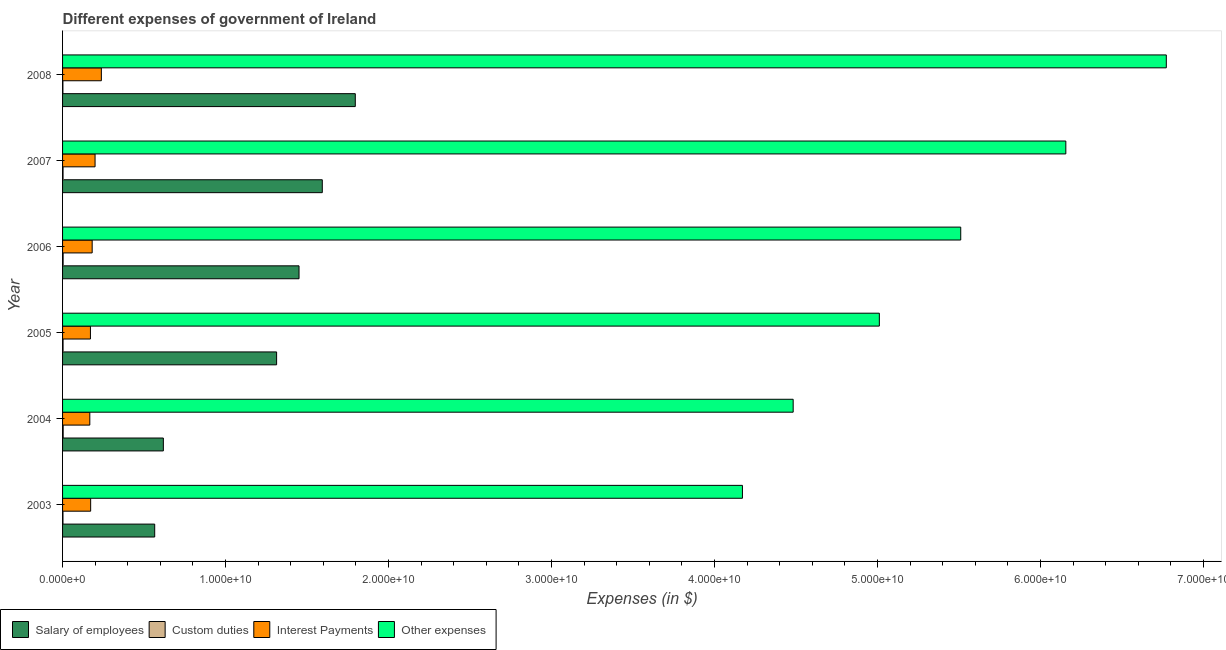How many groups of bars are there?
Your response must be concise. 6. How many bars are there on the 2nd tick from the top?
Offer a very short reply. 4. How many bars are there on the 4th tick from the bottom?
Offer a terse response. 4. What is the amount spent on custom duties in 2005?
Your answer should be compact. 3.06e+07. Across all years, what is the maximum amount spent on custom duties?
Your answer should be very brief. 3.67e+07. Across all years, what is the minimum amount spent on interest payments?
Make the answer very short. 1.67e+09. What is the total amount spent on other expenses in the graph?
Your answer should be very brief. 3.21e+11. What is the difference between the amount spent on interest payments in 2007 and that in 2008?
Provide a succinct answer. -3.86e+08. What is the difference between the amount spent on interest payments in 2003 and the amount spent on custom duties in 2006?
Offer a terse response. 1.69e+09. What is the average amount spent on other expenses per year?
Make the answer very short. 5.35e+1. In the year 2003, what is the difference between the amount spent on other expenses and amount spent on interest payments?
Your answer should be compact. 4.00e+1. What is the ratio of the amount spent on salary of employees in 2005 to that in 2006?
Make the answer very short. 0.91. What is the difference between the highest and the second highest amount spent on salary of employees?
Give a very brief answer. 2.02e+09. What is the difference between the highest and the lowest amount spent on interest payments?
Offer a terse response. 7.08e+08. In how many years, is the amount spent on custom duties greater than the average amount spent on custom duties taken over all years?
Offer a terse response. 4. What does the 1st bar from the top in 2004 represents?
Offer a terse response. Other expenses. What does the 3rd bar from the bottom in 2008 represents?
Your answer should be compact. Interest Payments. Are all the bars in the graph horizontal?
Offer a terse response. Yes. What is the difference between two consecutive major ticks on the X-axis?
Offer a very short reply. 1.00e+1. Does the graph contain grids?
Your answer should be compact. No. Where does the legend appear in the graph?
Your answer should be compact. Bottom left. What is the title of the graph?
Make the answer very short. Different expenses of government of Ireland. What is the label or title of the X-axis?
Your answer should be compact. Expenses (in $). What is the Expenses (in $) of Salary of employees in 2003?
Offer a terse response. 5.65e+09. What is the Expenses (in $) in Custom duties in 2003?
Provide a short and direct response. 2.45e+07. What is the Expenses (in $) of Interest Payments in 2003?
Offer a very short reply. 1.72e+09. What is the Expenses (in $) of Other expenses in 2003?
Offer a terse response. 4.17e+1. What is the Expenses (in $) in Salary of employees in 2004?
Keep it short and to the point. 6.18e+09. What is the Expenses (in $) in Custom duties in 2004?
Offer a terse response. 3.67e+07. What is the Expenses (in $) in Interest Payments in 2004?
Ensure brevity in your answer.  1.67e+09. What is the Expenses (in $) of Other expenses in 2004?
Your answer should be very brief. 4.48e+1. What is the Expenses (in $) of Salary of employees in 2005?
Provide a short and direct response. 1.31e+1. What is the Expenses (in $) of Custom duties in 2005?
Offer a very short reply. 3.06e+07. What is the Expenses (in $) in Interest Payments in 2005?
Make the answer very short. 1.71e+09. What is the Expenses (in $) of Other expenses in 2005?
Make the answer very short. 5.01e+1. What is the Expenses (in $) in Salary of employees in 2006?
Provide a succinct answer. 1.45e+1. What is the Expenses (in $) of Custom duties in 2006?
Offer a terse response. 3.44e+07. What is the Expenses (in $) of Interest Payments in 2006?
Offer a terse response. 1.82e+09. What is the Expenses (in $) of Other expenses in 2006?
Keep it short and to the point. 5.51e+1. What is the Expenses (in $) in Salary of employees in 2007?
Your response must be concise. 1.59e+1. What is the Expenses (in $) of Custom duties in 2007?
Offer a very short reply. 2.95e+07. What is the Expenses (in $) of Interest Payments in 2007?
Keep it short and to the point. 1.99e+09. What is the Expenses (in $) in Other expenses in 2007?
Your answer should be very brief. 6.16e+1. What is the Expenses (in $) of Salary of employees in 2008?
Your answer should be very brief. 1.80e+1. What is the Expenses (in $) of Custom duties in 2008?
Make the answer very short. 2.06e+07. What is the Expenses (in $) in Interest Payments in 2008?
Provide a succinct answer. 2.38e+09. What is the Expenses (in $) in Other expenses in 2008?
Your answer should be compact. 6.77e+1. Across all years, what is the maximum Expenses (in $) in Salary of employees?
Provide a short and direct response. 1.80e+1. Across all years, what is the maximum Expenses (in $) in Custom duties?
Make the answer very short. 3.67e+07. Across all years, what is the maximum Expenses (in $) in Interest Payments?
Provide a succinct answer. 2.38e+09. Across all years, what is the maximum Expenses (in $) in Other expenses?
Give a very brief answer. 6.77e+1. Across all years, what is the minimum Expenses (in $) in Salary of employees?
Your response must be concise. 5.65e+09. Across all years, what is the minimum Expenses (in $) in Custom duties?
Your answer should be very brief. 2.06e+07. Across all years, what is the minimum Expenses (in $) of Interest Payments?
Your answer should be compact. 1.67e+09. Across all years, what is the minimum Expenses (in $) of Other expenses?
Ensure brevity in your answer.  4.17e+1. What is the total Expenses (in $) of Salary of employees in the graph?
Your answer should be compact. 7.34e+1. What is the total Expenses (in $) in Custom duties in the graph?
Offer a very short reply. 1.76e+08. What is the total Expenses (in $) of Interest Payments in the graph?
Give a very brief answer. 1.13e+1. What is the total Expenses (in $) of Other expenses in the graph?
Provide a succinct answer. 3.21e+11. What is the difference between the Expenses (in $) of Salary of employees in 2003 and that in 2004?
Offer a terse response. -5.31e+08. What is the difference between the Expenses (in $) in Custom duties in 2003 and that in 2004?
Give a very brief answer. -1.22e+07. What is the difference between the Expenses (in $) in Interest Payments in 2003 and that in 2004?
Provide a short and direct response. 5.13e+07. What is the difference between the Expenses (in $) of Other expenses in 2003 and that in 2004?
Your response must be concise. -3.11e+09. What is the difference between the Expenses (in $) in Salary of employees in 2003 and that in 2005?
Offer a terse response. -7.48e+09. What is the difference between the Expenses (in $) of Custom duties in 2003 and that in 2005?
Provide a succinct answer. -6.12e+06. What is the difference between the Expenses (in $) in Interest Payments in 2003 and that in 2005?
Give a very brief answer. 1.34e+07. What is the difference between the Expenses (in $) of Other expenses in 2003 and that in 2005?
Make the answer very short. -8.40e+09. What is the difference between the Expenses (in $) in Salary of employees in 2003 and that in 2006?
Your answer should be compact. -8.85e+09. What is the difference between the Expenses (in $) in Custom duties in 2003 and that in 2006?
Your answer should be compact. -9.89e+06. What is the difference between the Expenses (in $) of Interest Payments in 2003 and that in 2006?
Make the answer very short. -9.33e+07. What is the difference between the Expenses (in $) in Other expenses in 2003 and that in 2006?
Provide a succinct answer. -1.34e+1. What is the difference between the Expenses (in $) in Salary of employees in 2003 and that in 2007?
Provide a short and direct response. -1.03e+1. What is the difference between the Expenses (in $) of Custom duties in 2003 and that in 2007?
Keep it short and to the point. -5.03e+06. What is the difference between the Expenses (in $) of Interest Payments in 2003 and that in 2007?
Keep it short and to the point. -2.71e+08. What is the difference between the Expenses (in $) of Other expenses in 2003 and that in 2007?
Provide a short and direct response. -1.98e+1. What is the difference between the Expenses (in $) in Salary of employees in 2003 and that in 2008?
Offer a very short reply. -1.23e+1. What is the difference between the Expenses (in $) of Custom duties in 2003 and that in 2008?
Your response must be concise. 3.87e+06. What is the difference between the Expenses (in $) in Interest Payments in 2003 and that in 2008?
Your answer should be compact. -6.56e+08. What is the difference between the Expenses (in $) in Other expenses in 2003 and that in 2008?
Offer a terse response. -2.60e+1. What is the difference between the Expenses (in $) in Salary of employees in 2004 and that in 2005?
Offer a terse response. -6.95e+09. What is the difference between the Expenses (in $) in Custom duties in 2004 and that in 2005?
Offer a very short reply. 6.12e+06. What is the difference between the Expenses (in $) of Interest Payments in 2004 and that in 2005?
Offer a terse response. -3.79e+07. What is the difference between the Expenses (in $) in Other expenses in 2004 and that in 2005?
Give a very brief answer. -5.29e+09. What is the difference between the Expenses (in $) in Salary of employees in 2004 and that in 2006?
Ensure brevity in your answer.  -8.32e+09. What is the difference between the Expenses (in $) of Custom duties in 2004 and that in 2006?
Offer a terse response. 2.35e+06. What is the difference between the Expenses (in $) in Interest Payments in 2004 and that in 2006?
Keep it short and to the point. -1.45e+08. What is the difference between the Expenses (in $) in Other expenses in 2004 and that in 2006?
Your response must be concise. -1.03e+1. What is the difference between the Expenses (in $) of Salary of employees in 2004 and that in 2007?
Your response must be concise. -9.75e+09. What is the difference between the Expenses (in $) in Custom duties in 2004 and that in 2007?
Give a very brief answer. 7.21e+06. What is the difference between the Expenses (in $) in Interest Payments in 2004 and that in 2007?
Provide a succinct answer. -3.22e+08. What is the difference between the Expenses (in $) in Other expenses in 2004 and that in 2007?
Make the answer very short. -1.67e+1. What is the difference between the Expenses (in $) of Salary of employees in 2004 and that in 2008?
Your answer should be compact. -1.18e+1. What is the difference between the Expenses (in $) in Custom duties in 2004 and that in 2008?
Your answer should be compact. 1.61e+07. What is the difference between the Expenses (in $) of Interest Payments in 2004 and that in 2008?
Offer a terse response. -7.08e+08. What is the difference between the Expenses (in $) of Other expenses in 2004 and that in 2008?
Ensure brevity in your answer.  -2.29e+1. What is the difference between the Expenses (in $) in Salary of employees in 2005 and that in 2006?
Offer a very short reply. -1.38e+09. What is the difference between the Expenses (in $) in Custom duties in 2005 and that in 2006?
Your response must be concise. -3.77e+06. What is the difference between the Expenses (in $) of Interest Payments in 2005 and that in 2006?
Your answer should be compact. -1.07e+08. What is the difference between the Expenses (in $) of Other expenses in 2005 and that in 2006?
Offer a very short reply. -4.99e+09. What is the difference between the Expenses (in $) in Salary of employees in 2005 and that in 2007?
Give a very brief answer. -2.80e+09. What is the difference between the Expenses (in $) in Custom duties in 2005 and that in 2007?
Offer a very short reply. 1.09e+06. What is the difference between the Expenses (in $) of Interest Payments in 2005 and that in 2007?
Make the answer very short. -2.84e+08. What is the difference between the Expenses (in $) of Other expenses in 2005 and that in 2007?
Provide a succinct answer. -1.14e+1. What is the difference between the Expenses (in $) of Salary of employees in 2005 and that in 2008?
Your answer should be very brief. -4.83e+09. What is the difference between the Expenses (in $) of Custom duties in 2005 and that in 2008?
Provide a short and direct response. 9.99e+06. What is the difference between the Expenses (in $) of Interest Payments in 2005 and that in 2008?
Make the answer very short. -6.70e+08. What is the difference between the Expenses (in $) in Other expenses in 2005 and that in 2008?
Make the answer very short. -1.76e+1. What is the difference between the Expenses (in $) in Salary of employees in 2006 and that in 2007?
Provide a succinct answer. -1.43e+09. What is the difference between the Expenses (in $) of Custom duties in 2006 and that in 2007?
Give a very brief answer. 4.86e+06. What is the difference between the Expenses (in $) in Interest Payments in 2006 and that in 2007?
Provide a succinct answer. -1.77e+08. What is the difference between the Expenses (in $) in Other expenses in 2006 and that in 2007?
Offer a terse response. -6.45e+09. What is the difference between the Expenses (in $) in Salary of employees in 2006 and that in 2008?
Provide a succinct answer. -3.45e+09. What is the difference between the Expenses (in $) in Custom duties in 2006 and that in 2008?
Give a very brief answer. 1.38e+07. What is the difference between the Expenses (in $) of Interest Payments in 2006 and that in 2008?
Your response must be concise. -5.63e+08. What is the difference between the Expenses (in $) of Other expenses in 2006 and that in 2008?
Offer a very short reply. -1.26e+1. What is the difference between the Expenses (in $) of Salary of employees in 2007 and that in 2008?
Ensure brevity in your answer.  -2.02e+09. What is the difference between the Expenses (in $) in Custom duties in 2007 and that in 2008?
Ensure brevity in your answer.  8.90e+06. What is the difference between the Expenses (in $) in Interest Payments in 2007 and that in 2008?
Offer a very short reply. -3.86e+08. What is the difference between the Expenses (in $) of Other expenses in 2007 and that in 2008?
Give a very brief answer. -6.16e+09. What is the difference between the Expenses (in $) of Salary of employees in 2003 and the Expenses (in $) of Custom duties in 2004?
Ensure brevity in your answer.  5.62e+09. What is the difference between the Expenses (in $) of Salary of employees in 2003 and the Expenses (in $) of Interest Payments in 2004?
Your answer should be very brief. 3.98e+09. What is the difference between the Expenses (in $) of Salary of employees in 2003 and the Expenses (in $) of Other expenses in 2004?
Your answer should be very brief. -3.92e+1. What is the difference between the Expenses (in $) in Custom duties in 2003 and the Expenses (in $) in Interest Payments in 2004?
Your answer should be compact. -1.65e+09. What is the difference between the Expenses (in $) in Custom duties in 2003 and the Expenses (in $) in Other expenses in 2004?
Offer a very short reply. -4.48e+1. What is the difference between the Expenses (in $) in Interest Payments in 2003 and the Expenses (in $) in Other expenses in 2004?
Offer a terse response. -4.31e+1. What is the difference between the Expenses (in $) of Salary of employees in 2003 and the Expenses (in $) of Custom duties in 2005?
Offer a terse response. 5.62e+09. What is the difference between the Expenses (in $) of Salary of employees in 2003 and the Expenses (in $) of Interest Payments in 2005?
Give a very brief answer. 3.94e+09. What is the difference between the Expenses (in $) of Salary of employees in 2003 and the Expenses (in $) of Other expenses in 2005?
Your answer should be compact. -4.45e+1. What is the difference between the Expenses (in $) in Custom duties in 2003 and the Expenses (in $) in Interest Payments in 2005?
Provide a succinct answer. -1.69e+09. What is the difference between the Expenses (in $) of Custom duties in 2003 and the Expenses (in $) of Other expenses in 2005?
Offer a terse response. -5.01e+1. What is the difference between the Expenses (in $) of Interest Payments in 2003 and the Expenses (in $) of Other expenses in 2005?
Ensure brevity in your answer.  -4.84e+1. What is the difference between the Expenses (in $) of Salary of employees in 2003 and the Expenses (in $) of Custom duties in 2006?
Your answer should be compact. 5.62e+09. What is the difference between the Expenses (in $) of Salary of employees in 2003 and the Expenses (in $) of Interest Payments in 2006?
Provide a short and direct response. 3.84e+09. What is the difference between the Expenses (in $) in Salary of employees in 2003 and the Expenses (in $) in Other expenses in 2006?
Your answer should be very brief. -4.95e+1. What is the difference between the Expenses (in $) of Custom duties in 2003 and the Expenses (in $) of Interest Payments in 2006?
Ensure brevity in your answer.  -1.79e+09. What is the difference between the Expenses (in $) of Custom duties in 2003 and the Expenses (in $) of Other expenses in 2006?
Offer a terse response. -5.51e+1. What is the difference between the Expenses (in $) of Interest Payments in 2003 and the Expenses (in $) of Other expenses in 2006?
Your answer should be compact. -5.34e+1. What is the difference between the Expenses (in $) in Salary of employees in 2003 and the Expenses (in $) in Custom duties in 2007?
Offer a terse response. 5.62e+09. What is the difference between the Expenses (in $) in Salary of employees in 2003 and the Expenses (in $) in Interest Payments in 2007?
Offer a terse response. 3.66e+09. What is the difference between the Expenses (in $) in Salary of employees in 2003 and the Expenses (in $) in Other expenses in 2007?
Offer a very short reply. -5.59e+1. What is the difference between the Expenses (in $) in Custom duties in 2003 and the Expenses (in $) in Interest Payments in 2007?
Your answer should be very brief. -1.97e+09. What is the difference between the Expenses (in $) in Custom duties in 2003 and the Expenses (in $) in Other expenses in 2007?
Provide a short and direct response. -6.15e+1. What is the difference between the Expenses (in $) in Interest Payments in 2003 and the Expenses (in $) in Other expenses in 2007?
Provide a succinct answer. -5.98e+1. What is the difference between the Expenses (in $) of Salary of employees in 2003 and the Expenses (in $) of Custom duties in 2008?
Provide a succinct answer. 5.63e+09. What is the difference between the Expenses (in $) in Salary of employees in 2003 and the Expenses (in $) in Interest Payments in 2008?
Make the answer very short. 3.27e+09. What is the difference between the Expenses (in $) in Salary of employees in 2003 and the Expenses (in $) in Other expenses in 2008?
Provide a succinct answer. -6.21e+1. What is the difference between the Expenses (in $) in Custom duties in 2003 and the Expenses (in $) in Interest Payments in 2008?
Your answer should be very brief. -2.36e+09. What is the difference between the Expenses (in $) of Custom duties in 2003 and the Expenses (in $) of Other expenses in 2008?
Give a very brief answer. -6.77e+1. What is the difference between the Expenses (in $) of Interest Payments in 2003 and the Expenses (in $) of Other expenses in 2008?
Provide a succinct answer. -6.60e+1. What is the difference between the Expenses (in $) in Salary of employees in 2004 and the Expenses (in $) in Custom duties in 2005?
Provide a short and direct response. 6.15e+09. What is the difference between the Expenses (in $) of Salary of employees in 2004 and the Expenses (in $) of Interest Payments in 2005?
Provide a succinct answer. 4.47e+09. What is the difference between the Expenses (in $) of Salary of employees in 2004 and the Expenses (in $) of Other expenses in 2005?
Provide a succinct answer. -4.39e+1. What is the difference between the Expenses (in $) of Custom duties in 2004 and the Expenses (in $) of Interest Payments in 2005?
Your response must be concise. -1.67e+09. What is the difference between the Expenses (in $) of Custom duties in 2004 and the Expenses (in $) of Other expenses in 2005?
Provide a succinct answer. -5.01e+1. What is the difference between the Expenses (in $) in Interest Payments in 2004 and the Expenses (in $) in Other expenses in 2005?
Give a very brief answer. -4.84e+1. What is the difference between the Expenses (in $) of Salary of employees in 2004 and the Expenses (in $) of Custom duties in 2006?
Your answer should be compact. 6.15e+09. What is the difference between the Expenses (in $) of Salary of employees in 2004 and the Expenses (in $) of Interest Payments in 2006?
Your answer should be compact. 4.37e+09. What is the difference between the Expenses (in $) in Salary of employees in 2004 and the Expenses (in $) in Other expenses in 2006?
Your answer should be compact. -4.89e+1. What is the difference between the Expenses (in $) of Custom duties in 2004 and the Expenses (in $) of Interest Payments in 2006?
Provide a short and direct response. -1.78e+09. What is the difference between the Expenses (in $) of Custom duties in 2004 and the Expenses (in $) of Other expenses in 2006?
Keep it short and to the point. -5.51e+1. What is the difference between the Expenses (in $) in Interest Payments in 2004 and the Expenses (in $) in Other expenses in 2006?
Keep it short and to the point. -5.34e+1. What is the difference between the Expenses (in $) in Salary of employees in 2004 and the Expenses (in $) in Custom duties in 2007?
Give a very brief answer. 6.15e+09. What is the difference between the Expenses (in $) of Salary of employees in 2004 and the Expenses (in $) of Interest Payments in 2007?
Offer a very short reply. 4.19e+09. What is the difference between the Expenses (in $) of Salary of employees in 2004 and the Expenses (in $) of Other expenses in 2007?
Offer a very short reply. -5.54e+1. What is the difference between the Expenses (in $) in Custom duties in 2004 and the Expenses (in $) in Interest Payments in 2007?
Your answer should be very brief. -1.96e+09. What is the difference between the Expenses (in $) of Custom duties in 2004 and the Expenses (in $) of Other expenses in 2007?
Your answer should be very brief. -6.15e+1. What is the difference between the Expenses (in $) of Interest Payments in 2004 and the Expenses (in $) of Other expenses in 2007?
Offer a terse response. -5.99e+1. What is the difference between the Expenses (in $) in Salary of employees in 2004 and the Expenses (in $) in Custom duties in 2008?
Give a very brief answer. 6.16e+09. What is the difference between the Expenses (in $) of Salary of employees in 2004 and the Expenses (in $) of Interest Payments in 2008?
Make the answer very short. 3.80e+09. What is the difference between the Expenses (in $) of Salary of employees in 2004 and the Expenses (in $) of Other expenses in 2008?
Your response must be concise. -6.15e+1. What is the difference between the Expenses (in $) of Custom duties in 2004 and the Expenses (in $) of Interest Payments in 2008?
Your answer should be very brief. -2.34e+09. What is the difference between the Expenses (in $) of Custom duties in 2004 and the Expenses (in $) of Other expenses in 2008?
Make the answer very short. -6.77e+1. What is the difference between the Expenses (in $) in Interest Payments in 2004 and the Expenses (in $) in Other expenses in 2008?
Your response must be concise. -6.60e+1. What is the difference between the Expenses (in $) of Salary of employees in 2005 and the Expenses (in $) of Custom duties in 2006?
Offer a terse response. 1.31e+1. What is the difference between the Expenses (in $) of Salary of employees in 2005 and the Expenses (in $) of Interest Payments in 2006?
Offer a terse response. 1.13e+1. What is the difference between the Expenses (in $) of Salary of employees in 2005 and the Expenses (in $) of Other expenses in 2006?
Your response must be concise. -4.20e+1. What is the difference between the Expenses (in $) of Custom duties in 2005 and the Expenses (in $) of Interest Payments in 2006?
Offer a terse response. -1.79e+09. What is the difference between the Expenses (in $) of Custom duties in 2005 and the Expenses (in $) of Other expenses in 2006?
Provide a short and direct response. -5.51e+1. What is the difference between the Expenses (in $) of Interest Payments in 2005 and the Expenses (in $) of Other expenses in 2006?
Make the answer very short. -5.34e+1. What is the difference between the Expenses (in $) in Salary of employees in 2005 and the Expenses (in $) in Custom duties in 2007?
Your response must be concise. 1.31e+1. What is the difference between the Expenses (in $) of Salary of employees in 2005 and the Expenses (in $) of Interest Payments in 2007?
Provide a succinct answer. 1.11e+1. What is the difference between the Expenses (in $) in Salary of employees in 2005 and the Expenses (in $) in Other expenses in 2007?
Offer a very short reply. -4.84e+1. What is the difference between the Expenses (in $) of Custom duties in 2005 and the Expenses (in $) of Interest Payments in 2007?
Your response must be concise. -1.96e+09. What is the difference between the Expenses (in $) of Custom duties in 2005 and the Expenses (in $) of Other expenses in 2007?
Give a very brief answer. -6.15e+1. What is the difference between the Expenses (in $) in Interest Payments in 2005 and the Expenses (in $) in Other expenses in 2007?
Provide a short and direct response. -5.98e+1. What is the difference between the Expenses (in $) in Salary of employees in 2005 and the Expenses (in $) in Custom duties in 2008?
Offer a very short reply. 1.31e+1. What is the difference between the Expenses (in $) in Salary of employees in 2005 and the Expenses (in $) in Interest Payments in 2008?
Ensure brevity in your answer.  1.08e+1. What is the difference between the Expenses (in $) of Salary of employees in 2005 and the Expenses (in $) of Other expenses in 2008?
Provide a short and direct response. -5.46e+1. What is the difference between the Expenses (in $) of Custom duties in 2005 and the Expenses (in $) of Interest Payments in 2008?
Provide a succinct answer. -2.35e+09. What is the difference between the Expenses (in $) of Custom duties in 2005 and the Expenses (in $) of Other expenses in 2008?
Offer a very short reply. -6.77e+1. What is the difference between the Expenses (in $) of Interest Payments in 2005 and the Expenses (in $) of Other expenses in 2008?
Offer a terse response. -6.60e+1. What is the difference between the Expenses (in $) in Salary of employees in 2006 and the Expenses (in $) in Custom duties in 2007?
Offer a very short reply. 1.45e+1. What is the difference between the Expenses (in $) in Salary of employees in 2006 and the Expenses (in $) in Interest Payments in 2007?
Ensure brevity in your answer.  1.25e+1. What is the difference between the Expenses (in $) in Salary of employees in 2006 and the Expenses (in $) in Other expenses in 2007?
Your answer should be compact. -4.70e+1. What is the difference between the Expenses (in $) in Custom duties in 2006 and the Expenses (in $) in Interest Payments in 2007?
Make the answer very short. -1.96e+09. What is the difference between the Expenses (in $) in Custom duties in 2006 and the Expenses (in $) in Other expenses in 2007?
Offer a very short reply. -6.15e+1. What is the difference between the Expenses (in $) in Interest Payments in 2006 and the Expenses (in $) in Other expenses in 2007?
Provide a short and direct response. -5.97e+1. What is the difference between the Expenses (in $) of Salary of employees in 2006 and the Expenses (in $) of Custom duties in 2008?
Give a very brief answer. 1.45e+1. What is the difference between the Expenses (in $) of Salary of employees in 2006 and the Expenses (in $) of Interest Payments in 2008?
Offer a very short reply. 1.21e+1. What is the difference between the Expenses (in $) of Salary of employees in 2006 and the Expenses (in $) of Other expenses in 2008?
Keep it short and to the point. -5.32e+1. What is the difference between the Expenses (in $) in Custom duties in 2006 and the Expenses (in $) in Interest Payments in 2008?
Offer a very short reply. -2.35e+09. What is the difference between the Expenses (in $) of Custom duties in 2006 and the Expenses (in $) of Other expenses in 2008?
Ensure brevity in your answer.  -6.77e+1. What is the difference between the Expenses (in $) in Interest Payments in 2006 and the Expenses (in $) in Other expenses in 2008?
Offer a very short reply. -6.59e+1. What is the difference between the Expenses (in $) of Salary of employees in 2007 and the Expenses (in $) of Custom duties in 2008?
Make the answer very short. 1.59e+1. What is the difference between the Expenses (in $) in Salary of employees in 2007 and the Expenses (in $) in Interest Payments in 2008?
Your answer should be compact. 1.36e+1. What is the difference between the Expenses (in $) in Salary of employees in 2007 and the Expenses (in $) in Other expenses in 2008?
Your answer should be very brief. -5.18e+1. What is the difference between the Expenses (in $) in Custom duties in 2007 and the Expenses (in $) in Interest Payments in 2008?
Your answer should be compact. -2.35e+09. What is the difference between the Expenses (in $) of Custom duties in 2007 and the Expenses (in $) of Other expenses in 2008?
Keep it short and to the point. -6.77e+1. What is the difference between the Expenses (in $) of Interest Payments in 2007 and the Expenses (in $) of Other expenses in 2008?
Your answer should be compact. -6.57e+1. What is the average Expenses (in $) of Salary of employees per year?
Keep it short and to the point. 1.22e+1. What is the average Expenses (in $) in Custom duties per year?
Offer a terse response. 2.94e+07. What is the average Expenses (in $) in Interest Payments per year?
Provide a short and direct response. 1.88e+09. What is the average Expenses (in $) in Other expenses per year?
Offer a terse response. 5.35e+1. In the year 2003, what is the difference between the Expenses (in $) of Salary of employees and Expenses (in $) of Custom duties?
Your answer should be very brief. 5.63e+09. In the year 2003, what is the difference between the Expenses (in $) of Salary of employees and Expenses (in $) of Interest Payments?
Offer a very short reply. 3.93e+09. In the year 2003, what is the difference between the Expenses (in $) of Salary of employees and Expenses (in $) of Other expenses?
Your answer should be very brief. -3.61e+1. In the year 2003, what is the difference between the Expenses (in $) of Custom duties and Expenses (in $) of Interest Payments?
Ensure brevity in your answer.  -1.70e+09. In the year 2003, what is the difference between the Expenses (in $) of Custom duties and Expenses (in $) of Other expenses?
Your response must be concise. -4.17e+1. In the year 2003, what is the difference between the Expenses (in $) of Interest Payments and Expenses (in $) of Other expenses?
Provide a succinct answer. -4.00e+1. In the year 2004, what is the difference between the Expenses (in $) of Salary of employees and Expenses (in $) of Custom duties?
Make the answer very short. 6.15e+09. In the year 2004, what is the difference between the Expenses (in $) in Salary of employees and Expenses (in $) in Interest Payments?
Offer a very short reply. 4.51e+09. In the year 2004, what is the difference between the Expenses (in $) of Salary of employees and Expenses (in $) of Other expenses?
Offer a very short reply. -3.86e+1. In the year 2004, what is the difference between the Expenses (in $) of Custom duties and Expenses (in $) of Interest Payments?
Your response must be concise. -1.64e+09. In the year 2004, what is the difference between the Expenses (in $) of Custom duties and Expenses (in $) of Other expenses?
Ensure brevity in your answer.  -4.48e+1. In the year 2004, what is the difference between the Expenses (in $) in Interest Payments and Expenses (in $) in Other expenses?
Give a very brief answer. -4.32e+1. In the year 2005, what is the difference between the Expenses (in $) of Salary of employees and Expenses (in $) of Custom duties?
Offer a very short reply. 1.31e+1. In the year 2005, what is the difference between the Expenses (in $) in Salary of employees and Expenses (in $) in Interest Payments?
Provide a short and direct response. 1.14e+1. In the year 2005, what is the difference between the Expenses (in $) of Salary of employees and Expenses (in $) of Other expenses?
Your answer should be very brief. -3.70e+1. In the year 2005, what is the difference between the Expenses (in $) of Custom duties and Expenses (in $) of Interest Payments?
Ensure brevity in your answer.  -1.68e+09. In the year 2005, what is the difference between the Expenses (in $) of Custom duties and Expenses (in $) of Other expenses?
Your response must be concise. -5.01e+1. In the year 2005, what is the difference between the Expenses (in $) in Interest Payments and Expenses (in $) in Other expenses?
Provide a succinct answer. -4.84e+1. In the year 2006, what is the difference between the Expenses (in $) in Salary of employees and Expenses (in $) in Custom duties?
Your answer should be very brief. 1.45e+1. In the year 2006, what is the difference between the Expenses (in $) in Salary of employees and Expenses (in $) in Interest Payments?
Ensure brevity in your answer.  1.27e+1. In the year 2006, what is the difference between the Expenses (in $) in Salary of employees and Expenses (in $) in Other expenses?
Offer a very short reply. -4.06e+1. In the year 2006, what is the difference between the Expenses (in $) in Custom duties and Expenses (in $) in Interest Payments?
Provide a short and direct response. -1.78e+09. In the year 2006, what is the difference between the Expenses (in $) in Custom duties and Expenses (in $) in Other expenses?
Offer a terse response. -5.51e+1. In the year 2006, what is the difference between the Expenses (in $) of Interest Payments and Expenses (in $) of Other expenses?
Ensure brevity in your answer.  -5.33e+1. In the year 2007, what is the difference between the Expenses (in $) of Salary of employees and Expenses (in $) of Custom duties?
Keep it short and to the point. 1.59e+1. In the year 2007, what is the difference between the Expenses (in $) of Salary of employees and Expenses (in $) of Interest Payments?
Offer a very short reply. 1.39e+1. In the year 2007, what is the difference between the Expenses (in $) of Salary of employees and Expenses (in $) of Other expenses?
Offer a very short reply. -4.56e+1. In the year 2007, what is the difference between the Expenses (in $) of Custom duties and Expenses (in $) of Interest Payments?
Provide a short and direct response. -1.96e+09. In the year 2007, what is the difference between the Expenses (in $) in Custom duties and Expenses (in $) in Other expenses?
Ensure brevity in your answer.  -6.15e+1. In the year 2007, what is the difference between the Expenses (in $) of Interest Payments and Expenses (in $) of Other expenses?
Keep it short and to the point. -5.96e+1. In the year 2008, what is the difference between the Expenses (in $) in Salary of employees and Expenses (in $) in Custom duties?
Your answer should be very brief. 1.79e+1. In the year 2008, what is the difference between the Expenses (in $) in Salary of employees and Expenses (in $) in Interest Payments?
Provide a short and direct response. 1.56e+1. In the year 2008, what is the difference between the Expenses (in $) in Salary of employees and Expenses (in $) in Other expenses?
Provide a short and direct response. -4.98e+1. In the year 2008, what is the difference between the Expenses (in $) in Custom duties and Expenses (in $) in Interest Payments?
Give a very brief answer. -2.36e+09. In the year 2008, what is the difference between the Expenses (in $) in Custom duties and Expenses (in $) in Other expenses?
Provide a succinct answer. -6.77e+1. In the year 2008, what is the difference between the Expenses (in $) in Interest Payments and Expenses (in $) in Other expenses?
Provide a short and direct response. -6.53e+1. What is the ratio of the Expenses (in $) of Salary of employees in 2003 to that in 2004?
Give a very brief answer. 0.91. What is the ratio of the Expenses (in $) of Custom duties in 2003 to that in 2004?
Offer a terse response. 0.67. What is the ratio of the Expenses (in $) of Interest Payments in 2003 to that in 2004?
Provide a short and direct response. 1.03. What is the ratio of the Expenses (in $) of Other expenses in 2003 to that in 2004?
Keep it short and to the point. 0.93. What is the ratio of the Expenses (in $) in Salary of employees in 2003 to that in 2005?
Give a very brief answer. 0.43. What is the ratio of the Expenses (in $) in Custom duties in 2003 to that in 2005?
Offer a very short reply. 0.8. What is the ratio of the Expenses (in $) of Interest Payments in 2003 to that in 2005?
Offer a terse response. 1.01. What is the ratio of the Expenses (in $) of Other expenses in 2003 to that in 2005?
Offer a very short reply. 0.83. What is the ratio of the Expenses (in $) of Salary of employees in 2003 to that in 2006?
Keep it short and to the point. 0.39. What is the ratio of the Expenses (in $) of Custom duties in 2003 to that in 2006?
Offer a very short reply. 0.71. What is the ratio of the Expenses (in $) in Interest Payments in 2003 to that in 2006?
Provide a succinct answer. 0.95. What is the ratio of the Expenses (in $) of Other expenses in 2003 to that in 2006?
Your answer should be compact. 0.76. What is the ratio of the Expenses (in $) of Salary of employees in 2003 to that in 2007?
Your response must be concise. 0.35. What is the ratio of the Expenses (in $) of Custom duties in 2003 to that in 2007?
Offer a very short reply. 0.83. What is the ratio of the Expenses (in $) of Interest Payments in 2003 to that in 2007?
Provide a short and direct response. 0.86. What is the ratio of the Expenses (in $) of Other expenses in 2003 to that in 2007?
Provide a short and direct response. 0.68. What is the ratio of the Expenses (in $) of Salary of employees in 2003 to that in 2008?
Your answer should be very brief. 0.31. What is the ratio of the Expenses (in $) in Custom duties in 2003 to that in 2008?
Offer a terse response. 1.19. What is the ratio of the Expenses (in $) in Interest Payments in 2003 to that in 2008?
Your response must be concise. 0.72. What is the ratio of the Expenses (in $) in Other expenses in 2003 to that in 2008?
Ensure brevity in your answer.  0.62. What is the ratio of the Expenses (in $) of Salary of employees in 2004 to that in 2005?
Keep it short and to the point. 0.47. What is the ratio of the Expenses (in $) of Custom duties in 2004 to that in 2005?
Your response must be concise. 1.2. What is the ratio of the Expenses (in $) of Interest Payments in 2004 to that in 2005?
Ensure brevity in your answer.  0.98. What is the ratio of the Expenses (in $) in Other expenses in 2004 to that in 2005?
Give a very brief answer. 0.89. What is the ratio of the Expenses (in $) in Salary of employees in 2004 to that in 2006?
Give a very brief answer. 0.43. What is the ratio of the Expenses (in $) of Custom duties in 2004 to that in 2006?
Offer a terse response. 1.07. What is the ratio of the Expenses (in $) of Interest Payments in 2004 to that in 2006?
Give a very brief answer. 0.92. What is the ratio of the Expenses (in $) in Other expenses in 2004 to that in 2006?
Make the answer very short. 0.81. What is the ratio of the Expenses (in $) in Salary of employees in 2004 to that in 2007?
Offer a terse response. 0.39. What is the ratio of the Expenses (in $) of Custom duties in 2004 to that in 2007?
Offer a very short reply. 1.24. What is the ratio of the Expenses (in $) of Interest Payments in 2004 to that in 2007?
Give a very brief answer. 0.84. What is the ratio of the Expenses (in $) in Other expenses in 2004 to that in 2007?
Keep it short and to the point. 0.73. What is the ratio of the Expenses (in $) in Salary of employees in 2004 to that in 2008?
Give a very brief answer. 0.34. What is the ratio of the Expenses (in $) in Custom duties in 2004 to that in 2008?
Your answer should be compact. 1.78. What is the ratio of the Expenses (in $) of Interest Payments in 2004 to that in 2008?
Your response must be concise. 0.7. What is the ratio of the Expenses (in $) of Other expenses in 2004 to that in 2008?
Ensure brevity in your answer.  0.66. What is the ratio of the Expenses (in $) in Salary of employees in 2005 to that in 2006?
Make the answer very short. 0.91. What is the ratio of the Expenses (in $) of Custom duties in 2005 to that in 2006?
Your response must be concise. 0.89. What is the ratio of the Expenses (in $) of Interest Payments in 2005 to that in 2006?
Give a very brief answer. 0.94. What is the ratio of the Expenses (in $) in Other expenses in 2005 to that in 2006?
Offer a terse response. 0.91. What is the ratio of the Expenses (in $) in Salary of employees in 2005 to that in 2007?
Ensure brevity in your answer.  0.82. What is the ratio of the Expenses (in $) in Custom duties in 2005 to that in 2007?
Give a very brief answer. 1.04. What is the ratio of the Expenses (in $) in Interest Payments in 2005 to that in 2007?
Provide a succinct answer. 0.86. What is the ratio of the Expenses (in $) of Other expenses in 2005 to that in 2007?
Make the answer very short. 0.81. What is the ratio of the Expenses (in $) in Salary of employees in 2005 to that in 2008?
Give a very brief answer. 0.73. What is the ratio of the Expenses (in $) in Custom duties in 2005 to that in 2008?
Your answer should be very brief. 1.49. What is the ratio of the Expenses (in $) in Interest Payments in 2005 to that in 2008?
Provide a succinct answer. 0.72. What is the ratio of the Expenses (in $) in Other expenses in 2005 to that in 2008?
Ensure brevity in your answer.  0.74. What is the ratio of the Expenses (in $) in Salary of employees in 2006 to that in 2007?
Your answer should be very brief. 0.91. What is the ratio of the Expenses (in $) in Custom duties in 2006 to that in 2007?
Your answer should be very brief. 1.16. What is the ratio of the Expenses (in $) of Interest Payments in 2006 to that in 2007?
Offer a terse response. 0.91. What is the ratio of the Expenses (in $) in Other expenses in 2006 to that in 2007?
Provide a succinct answer. 0.9. What is the ratio of the Expenses (in $) in Salary of employees in 2006 to that in 2008?
Give a very brief answer. 0.81. What is the ratio of the Expenses (in $) in Custom duties in 2006 to that in 2008?
Your answer should be very brief. 1.67. What is the ratio of the Expenses (in $) in Interest Payments in 2006 to that in 2008?
Provide a succinct answer. 0.76. What is the ratio of the Expenses (in $) of Other expenses in 2006 to that in 2008?
Make the answer very short. 0.81. What is the ratio of the Expenses (in $) of Salary of employees in 2007 to that in 2008?
Your answer should be compact. 0.89. What is the ratio of the Expenses (in $) of Custom duties in 2007 to that in 2008?
Provide a succinct answer. 1.43. What is the ratio of the Expenses (in $) of Interest Payments in 2007 to that in 2008?
Your response must be concise. 0.84. What is the ratio of the Expenses (in $) of Other expenses in 2007 to that in 2008?
Give a very brief answer. 0.91. What is the difference between the highest and the second highest Expenses (in $) in Salary of employees?
Your answer should be very brief. 2.02e+09. What is the difference between the highest and the second highest Expenses (in $) in Custom duties?
Keep it short and to the point. 2.35e+06. What is the difference between the highest and the second highest Expenses (in $) in Interest Payments?
Your answer should be compact. 3.86e+08. What is the difference between the highest and the second highest Expenses (in $) in Other expenses?
Offer a very short reply. 6.16e+09. What is the difference between the highest and the lowest Expenses (in $) in Salary of employees?
Provide a short and direct response. 1.23e+1. What is the difference between the highest and the lowest Expenses (in $) of Custom duties?
Ensure brevity in your answer.  1.61e+07. What is the difference between the highest and the lowest Expenses (in $) of Interest Payments?
Provide a short and direct response. 7.08e+08. What is the difference between the highest and the lowest Expenses (in $) of Other expenses?
Offer a terse response. 2.60e+1. 